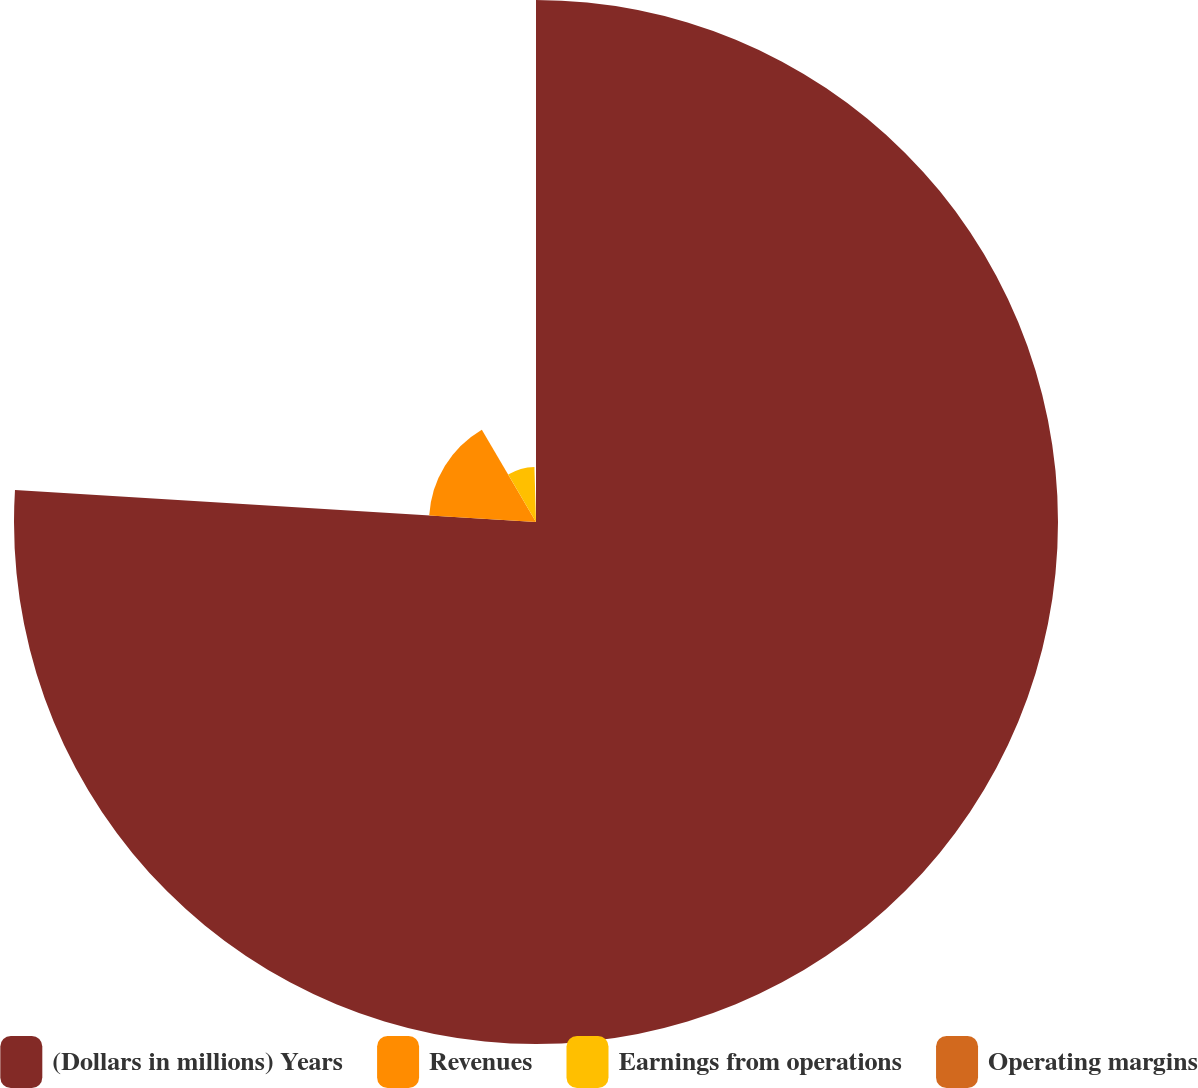<chart> <loc_0><loc_0><loc_500><loc_500><pie_chart><fcel>(Dollars in millions) Years<fcel>Revenues<fcel>Earnings from operations<fcel>Operating margins<nl><fcel>75.97%<fcel>15.57%<fcel>8.0%<fcel>0.45%<nl></chart> 